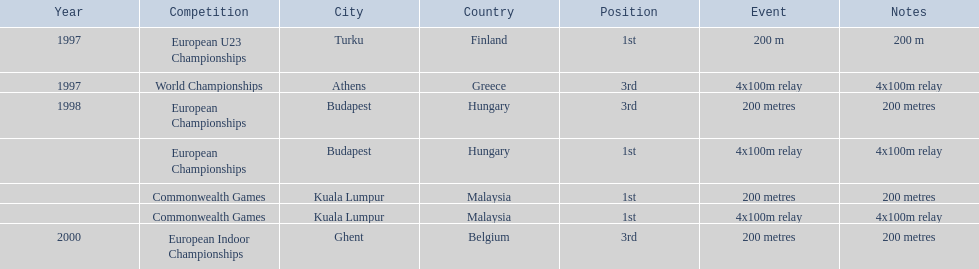List the other competitions besides european u23 championship that came in 1st position? European Championships, Commonwealth Games, Commonwealth Games. 